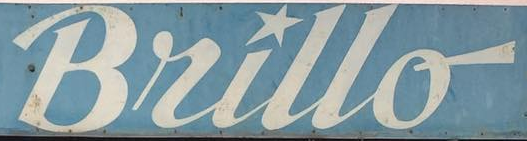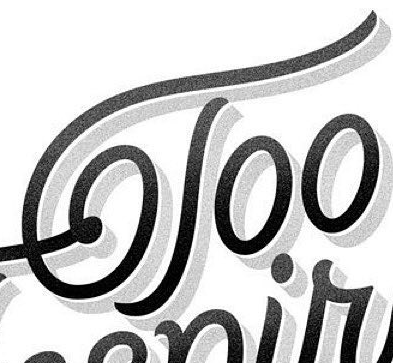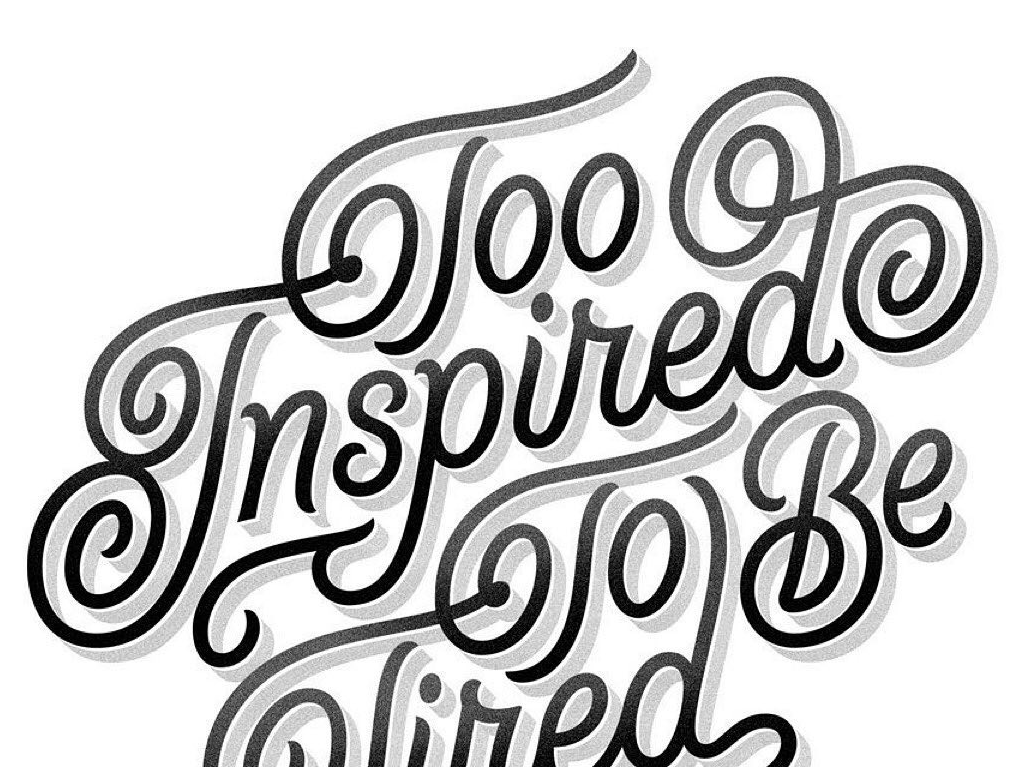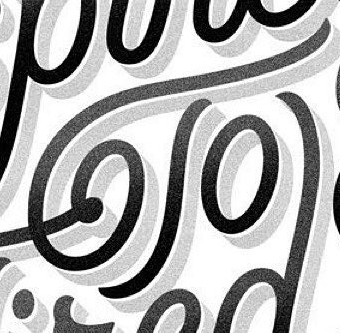What words can you see in these images in sequence, separated by a semicolon? Bullo; Too; Inspired; To 